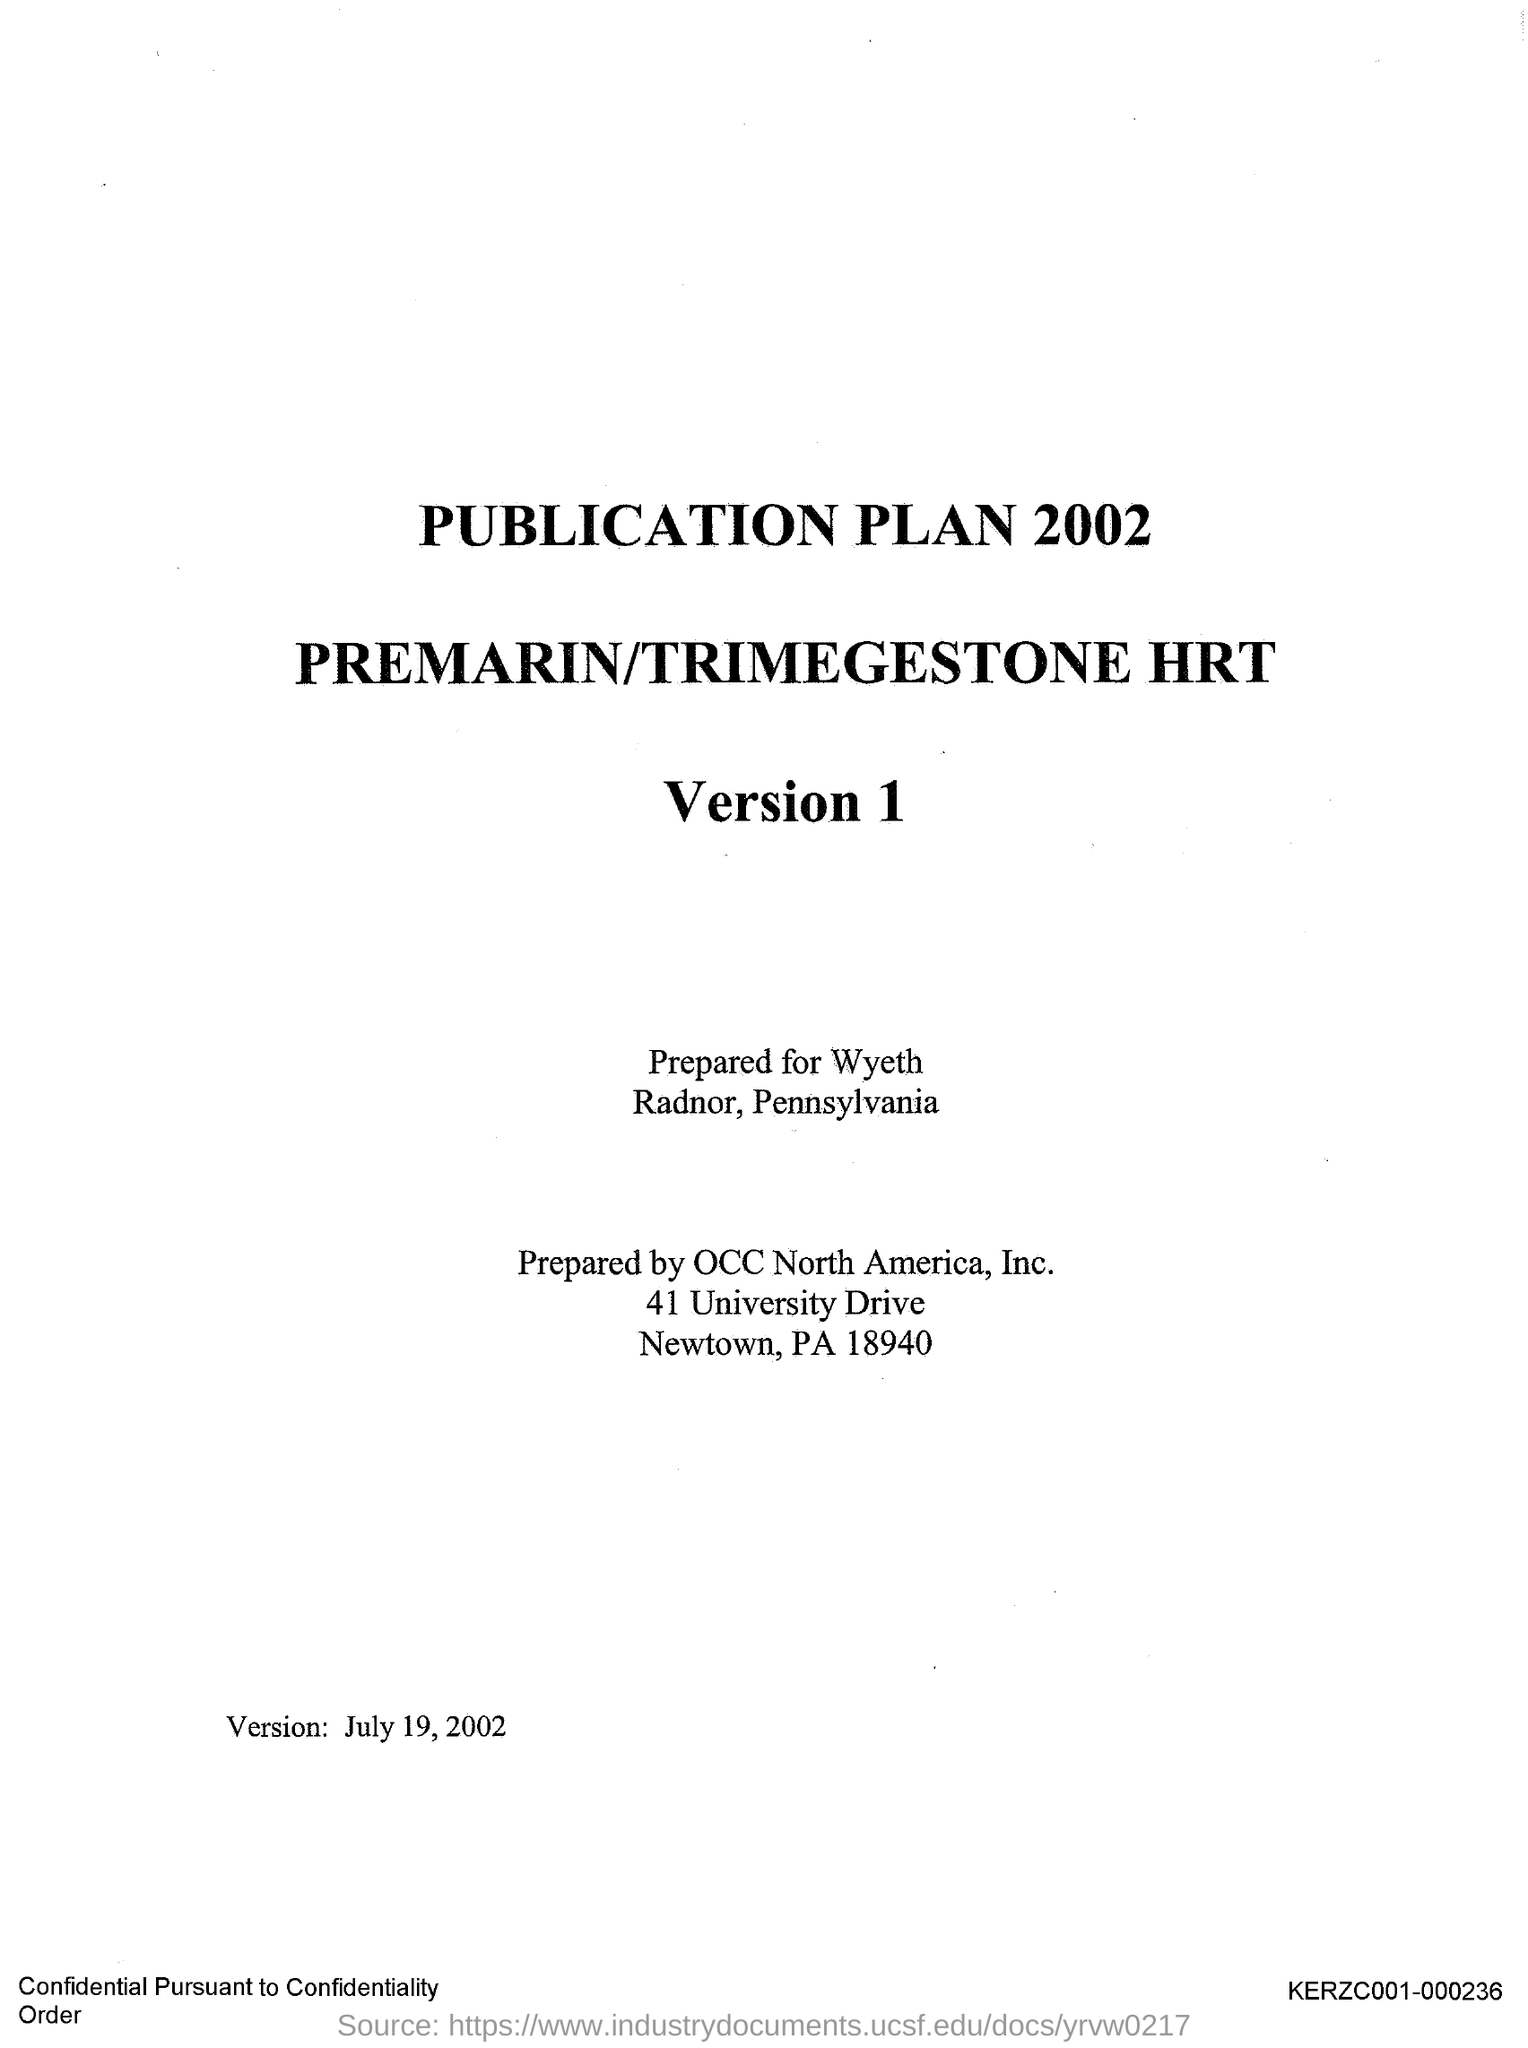Indicate a few pertinent items in this graphic. The third title in the document is Version 1. The second title in this document is 'Premarin/Trimegestone HRT.' The document is prepared for Wyeth company. The document is prepared by OCC North America, Inc. The first title in the document is 'Publication plan 2002.' 